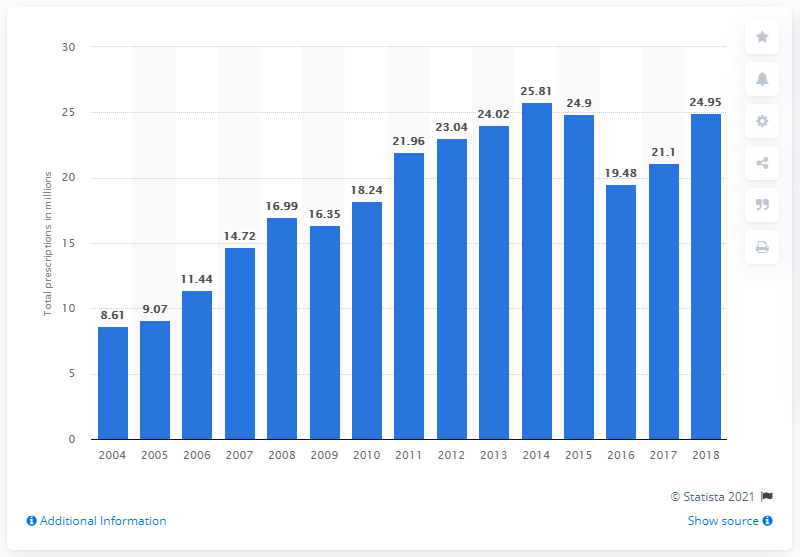Outline some significant characteristics in this image. In 2018, tramadol hydrochloride was prescribed a total of 24.9 times. 